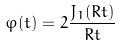Convert formula to latex. <formula><loc_0><loc_0><loc_500><loc_500>\varphi ( t ) = 2 \frac { J _ { 1 } ( R t ) } { R t }</formula> 